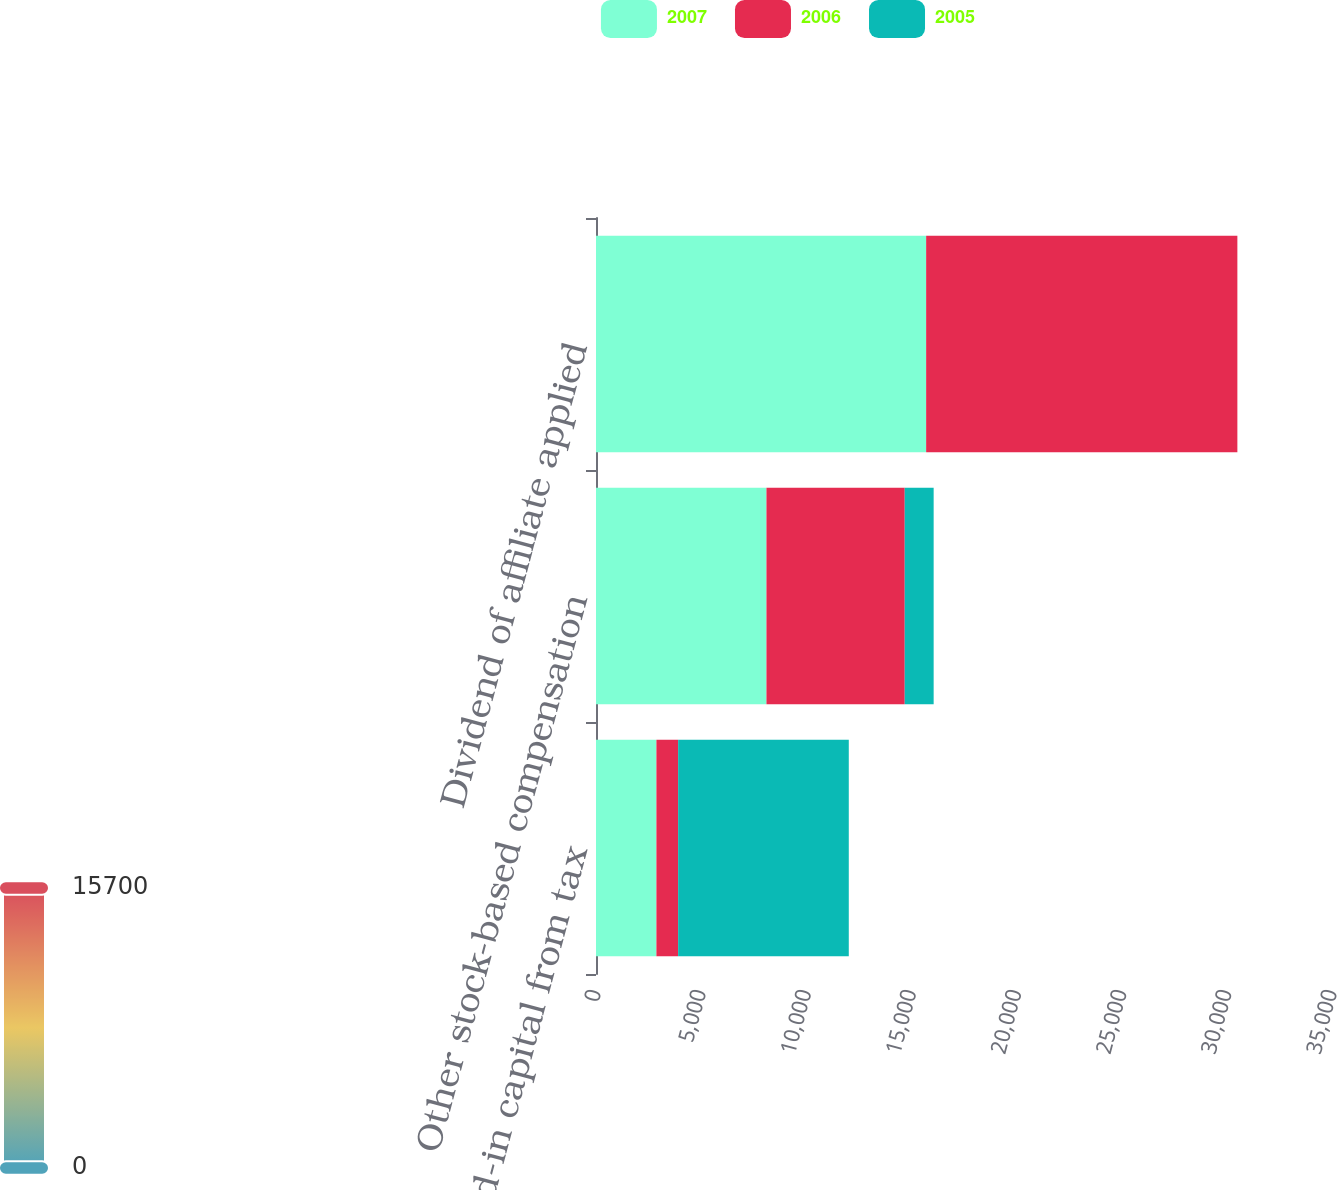<chart> <loc_0><loc_0><loc_500><loc_500><stacked_bar_chart><ecel><fcel>Paid-in capital from tax<fcel>Other stock-based compensation<fcel>Dividend of affiliate applied<nl><fcel>2007<fcel>2873<fcel>8106<fcel>15700<nl><fcel>2006<fcel>1033<fcel>6576<fcel>14800<nl><fcel>2005<fcel>8115<fcel>1375<fcel>0<nl></chart> 